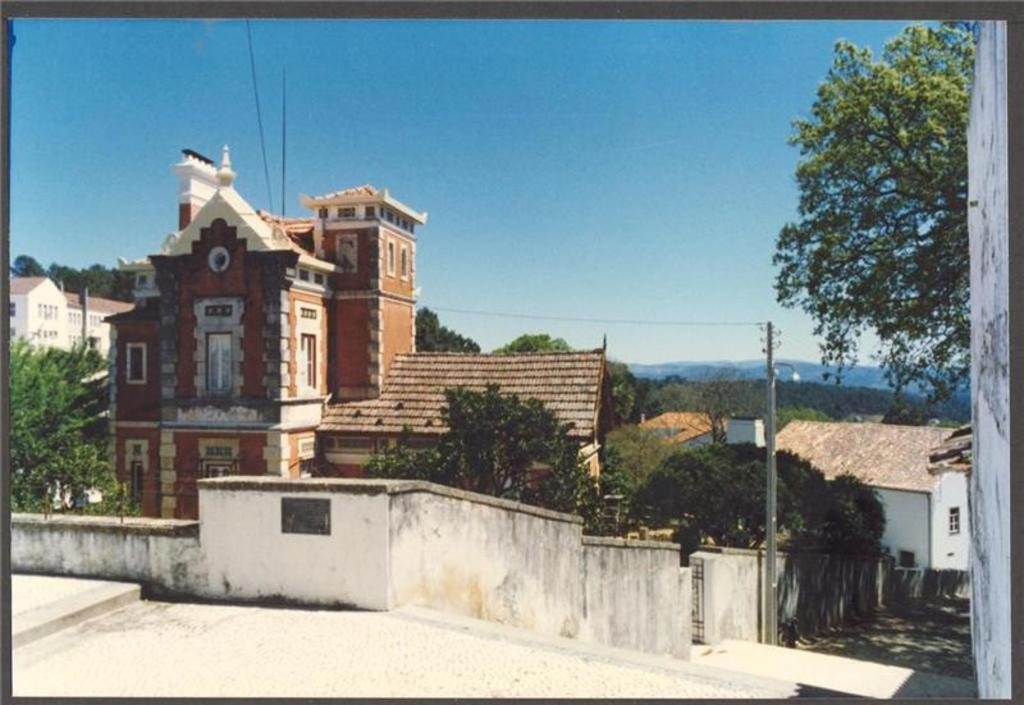What type of structure is present in the image? There is a current pole in the image. What can be seen on the buildings in the image? The buildings in the image have windows. What type of natural elements are visible in the image? Trees are visible in the image. What architectural feature is present in the image? There are stairs in the image. What type of man-made structure is present in the image? There is a wall in the image. How many stems can be seen growing from the box in the image? There is no box or stem present in the image. 